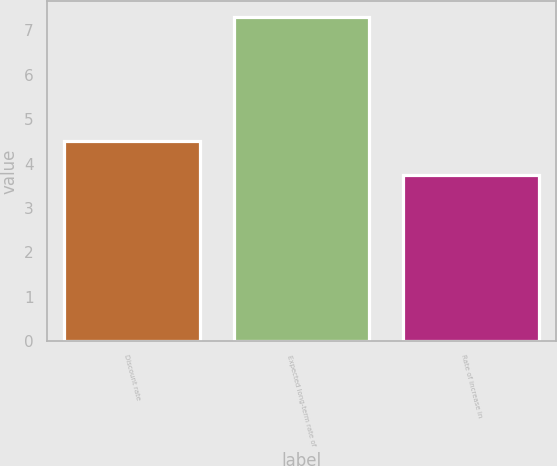<chart> <loc_0><loc_0><loc_500><loc_500><bar_chart><fcel>Discount rate<fcel>Expected long-term rate of<fcel>Rate of increase in<nl><fcel>4.5<fcel>7.3<fcel>3.75<nl></chart> 